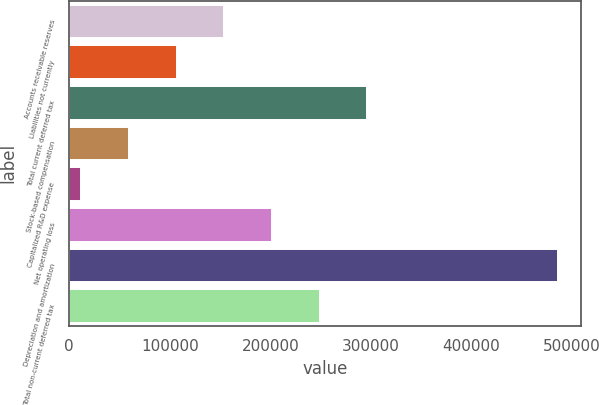<chart> <loc_0><loc_0><loc_500><loc_500><bar_chart><fcel>Accounts receivable reserves<fcel>Liabilities not currently<fcel>Total current deferred tax<fcel>Stock-based compensation<fcel>Capitalized R&D expense<fcel>Net operating loss<fcel>Depreciation and amortization<fcel>Total non-current deferred tax<nl><fcel>153125<fcel>105689<fcel>295433<fcel>58253<fcel>10413<fcel>200561<fcel>484773<fcel>247997<nl></chart> 